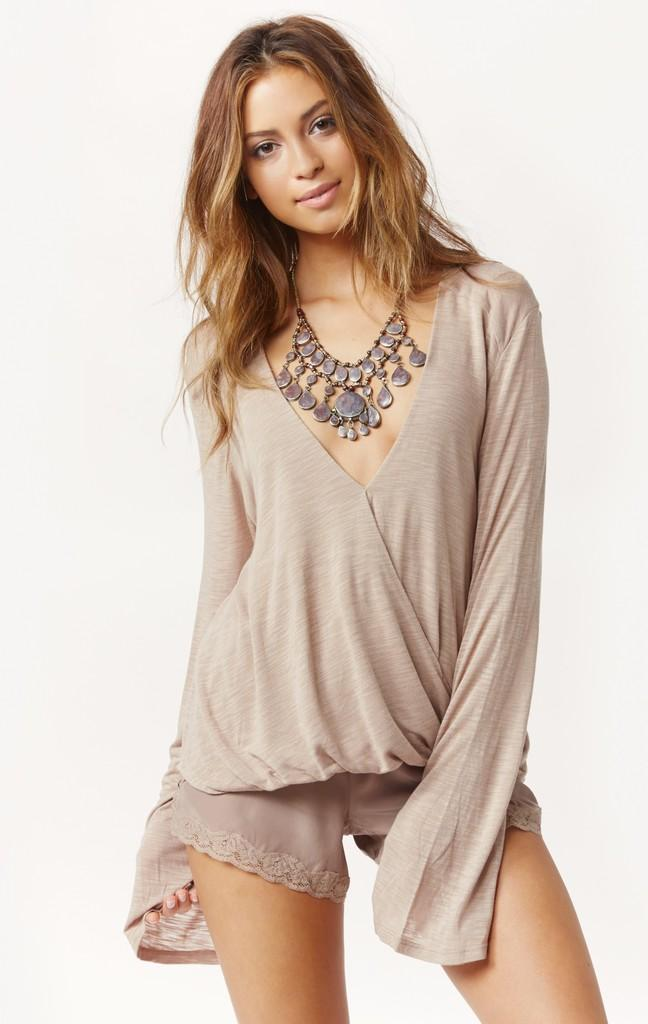Who is the main subject in the image? There is a woman in the image. Where is the woman located in the image? The woman is in the middle of the image. What is the woman's facial expression in the image? The woman is smiling in the image. What type of comb is the woman using in the image? There is no comb present in the image. Is the woman sleeping in the image? No, the woman is not sleeping in the image; she is smiling. 